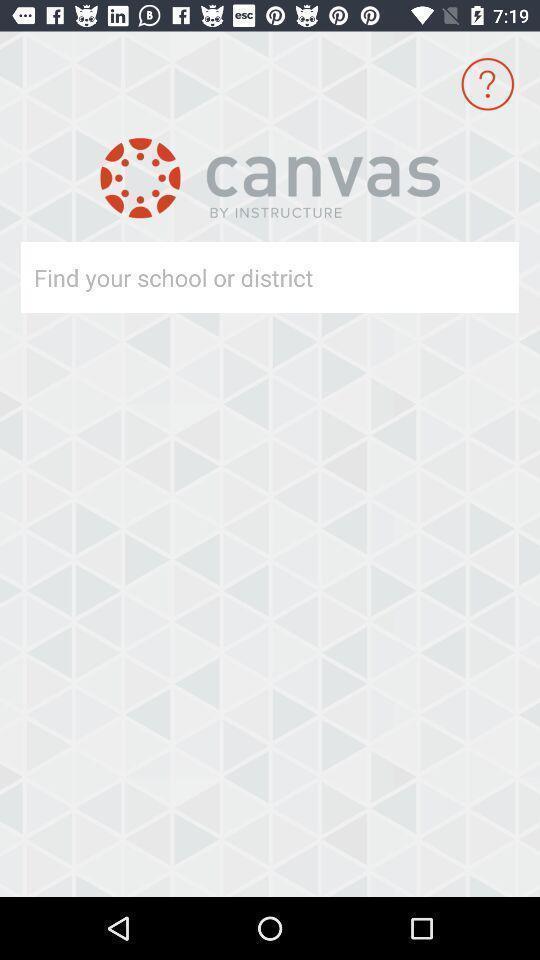Provide a textual representation of this image. Page displaying search option for school. 